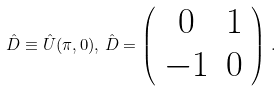Convert formula to latex. <formula><loc_0><loc_0><loc_500><loc_500>\hat { D } \equiv \hat { U } ( \pi , 0 ) , \, \hat { D } = \left ( \begin{array} { c c } 0 & 1 \\ - 1 & 0 \end{array} \right ) \, .</formula> 